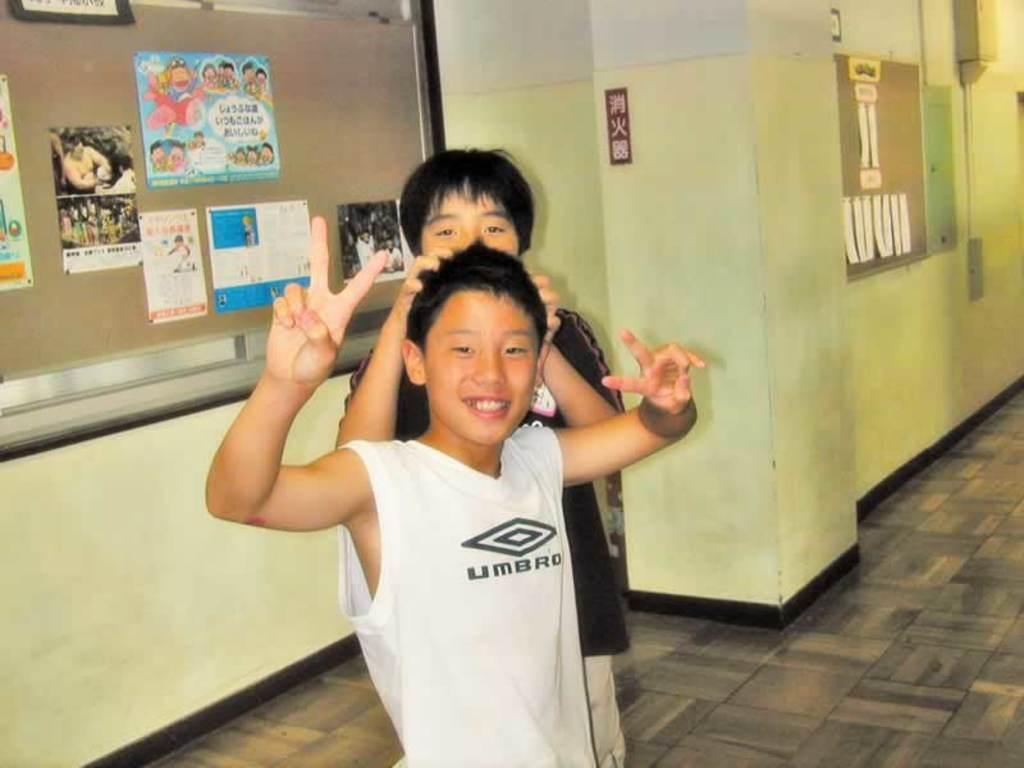Please provide a concise description of this image. In the center of the image we can see boys standing. In the background there are boards placed on the wall. 